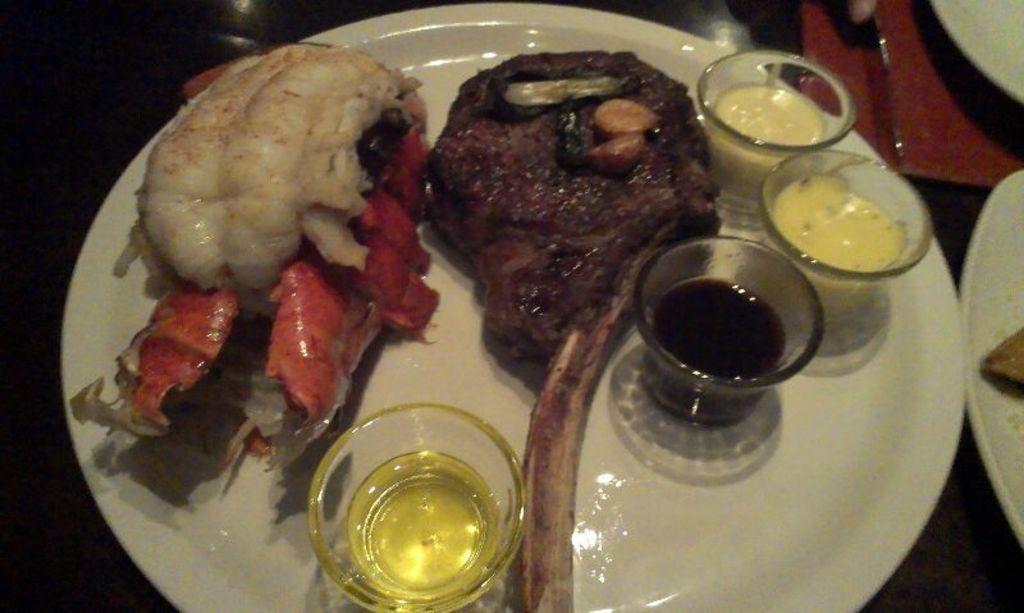How would you summarize this image in a sentence or two? In this picture we can see a plate, we can see some food and four cups present in this plate. 